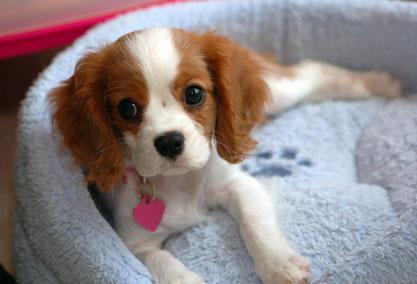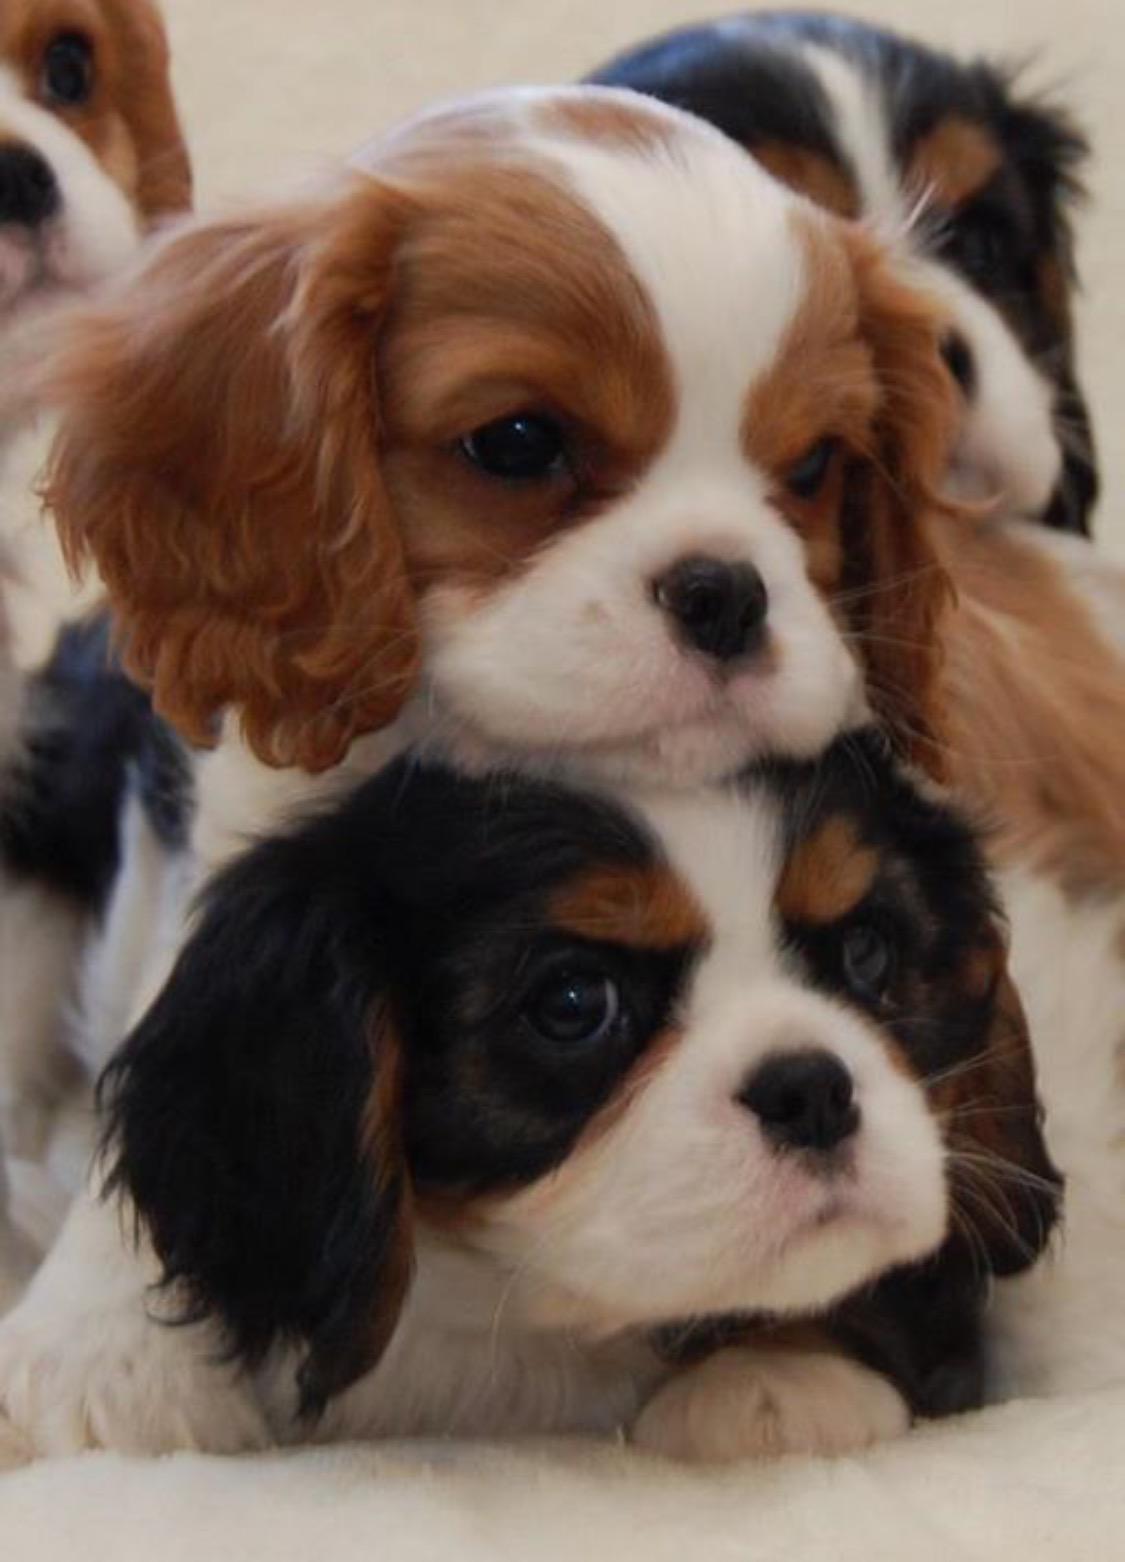The first image is the image on the left, the second image is the image on the right. Considering the images on both sides, is "Left image contains a puppy wearing a pink heart charm on its collar." valid? Answer yes or no. Yes. The first image is the image on the left, the second image is the image on the right. Considering the images on both sides, is "There are at least two puppies in the right image." valid? Answer yes or no. Yes. 